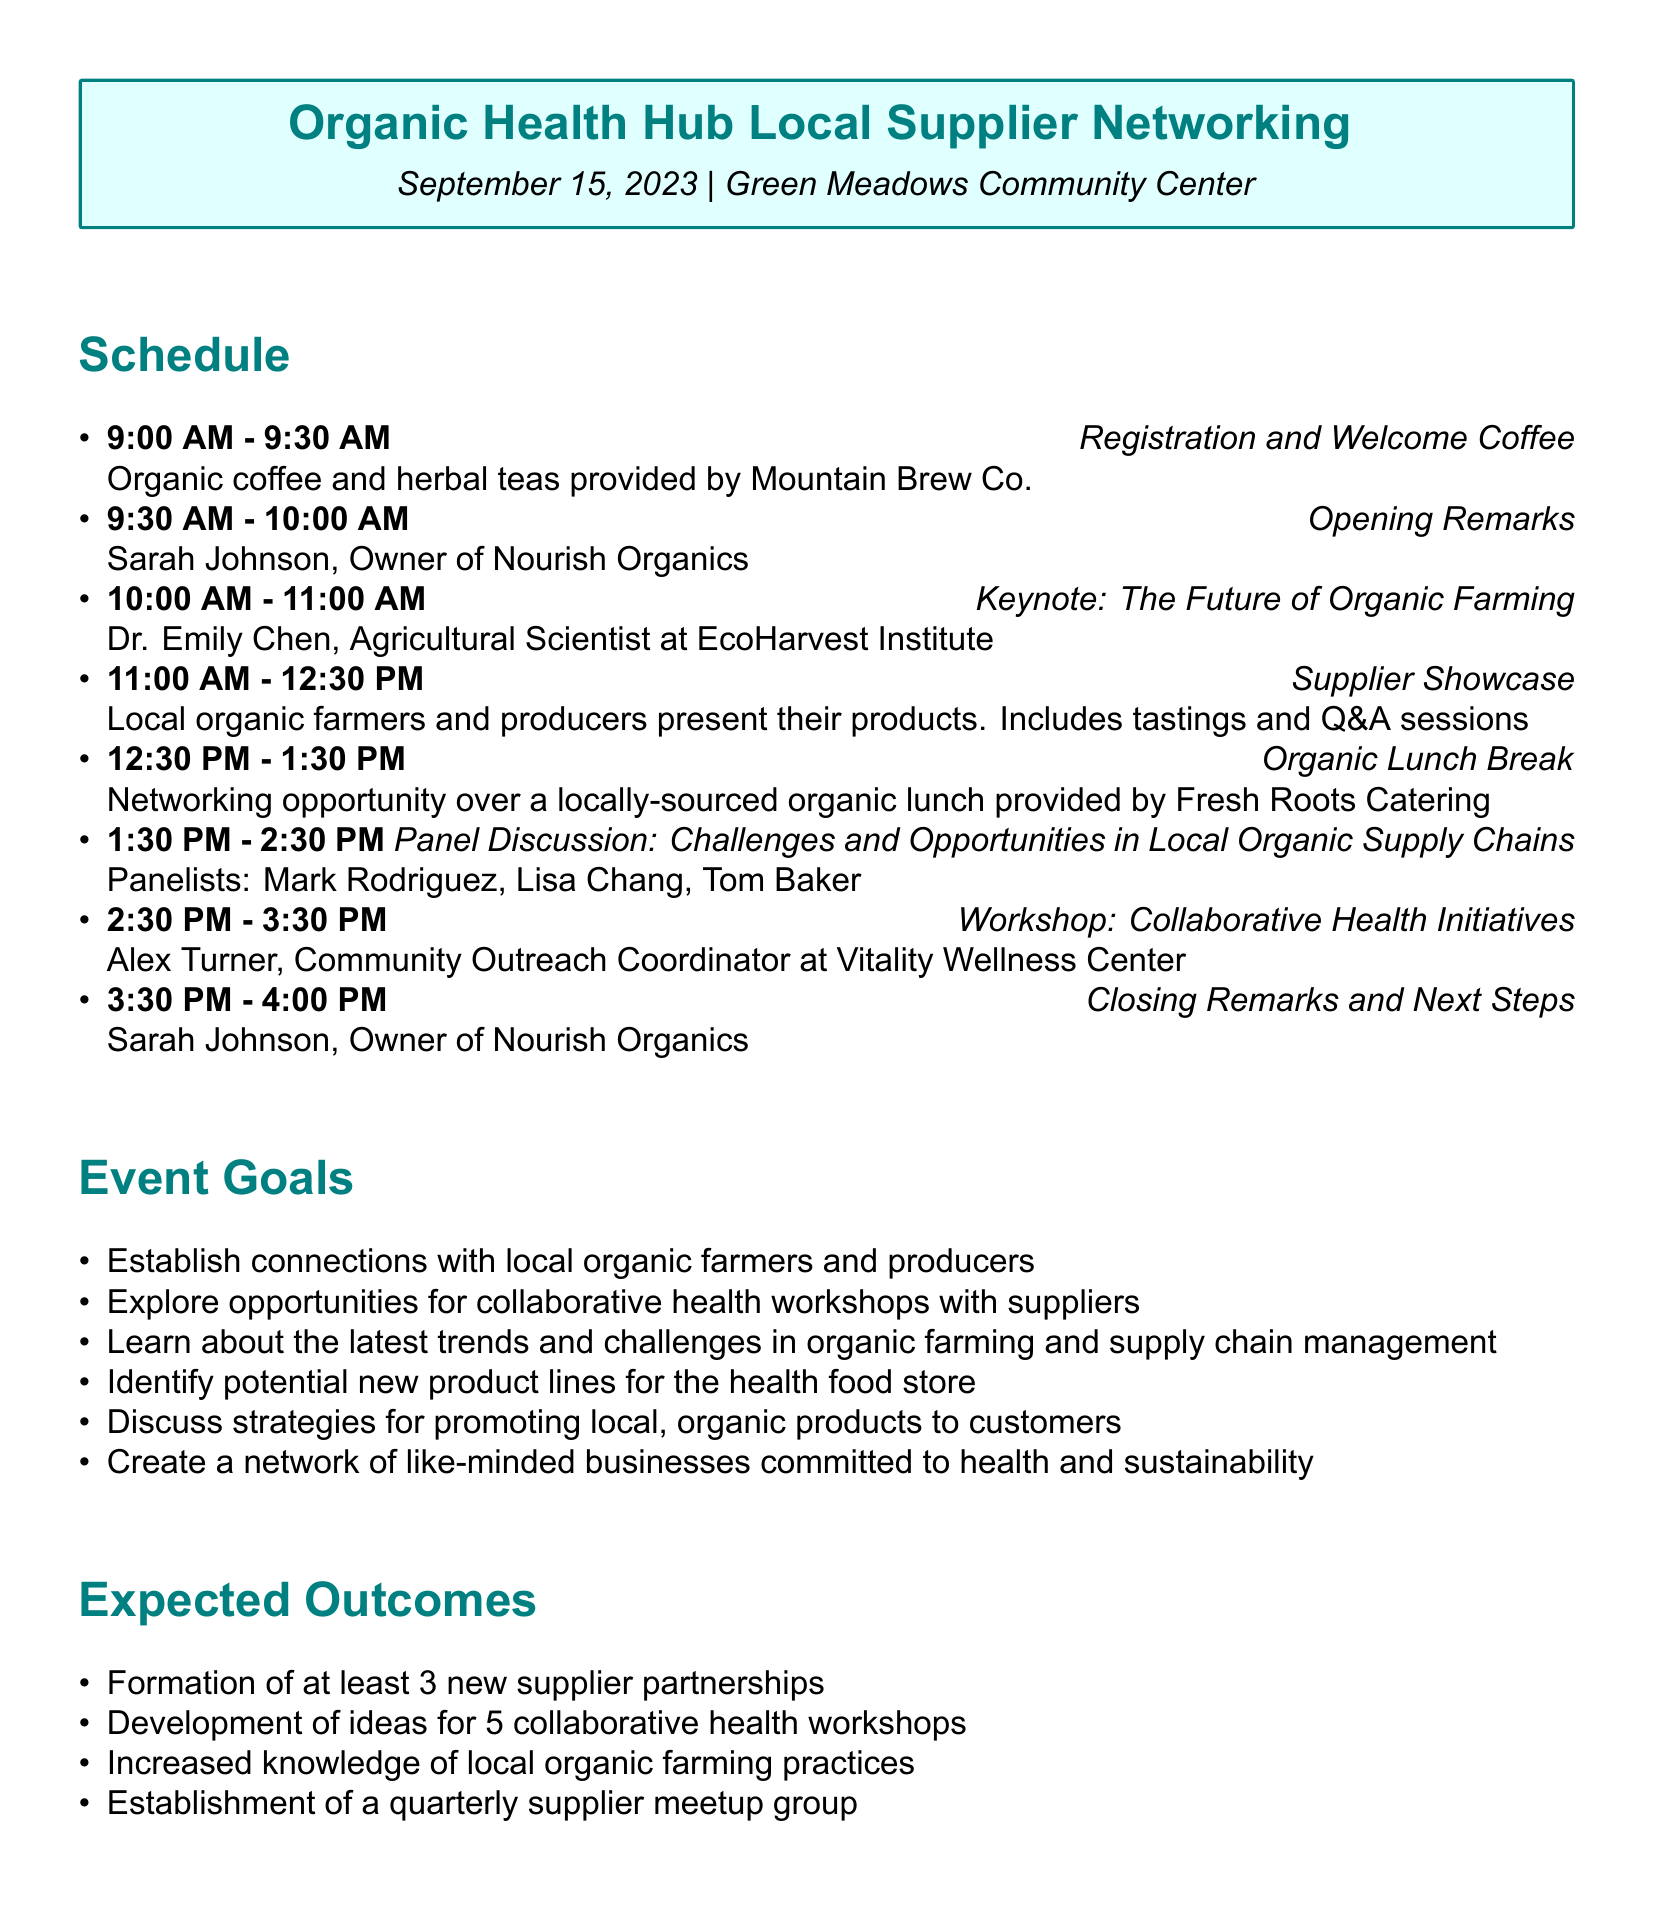What is the event name? The event name is the title of the document, which identifies the event being organized.
Answer: Organic Health Hub Local Supplier Networking When is the event scheduled? The date of the event is explicitly stated near the top of the document.
Answer: September 15, 2023 Who is the speaker for the opening remarks? This information can be found in the schedule section, as it lists the speaker for that activity.
Answer: Sarah Johnson, Owner of Nourish Organics What activity follows the Supplier Showcase? The schedule allows us to determine the sequence of activities during the event.
Answer: Organic Lunch Break How long is the workshop on Collaborative Health Initiatives? The duration of the workshop is detailed in the schedule section under that specific activity.
Answer: 1 hour What are the expected outcomes of the event? The expected outcomes are listed explicitly, and we can look for the specific items mentioned.
Answer: Formation of at least 3 new supplier partnerships How many panelists are participating in the panel discussion? The number of panelists can be inferred from the list provided in the schedule for that discussion.
Answer: 3 What is one goal of the event? The goals of the event are outlined in a list, providing specific aims for the gathering.
Answer: Establish connections with local organic farmers and producers Who is facilitating the workshop? The facilitator's name is mentioned directly in the workshop section of the agenda.
Answer: Alex Turner, Community Outreach Coordinator at Vitality Wellness Center 